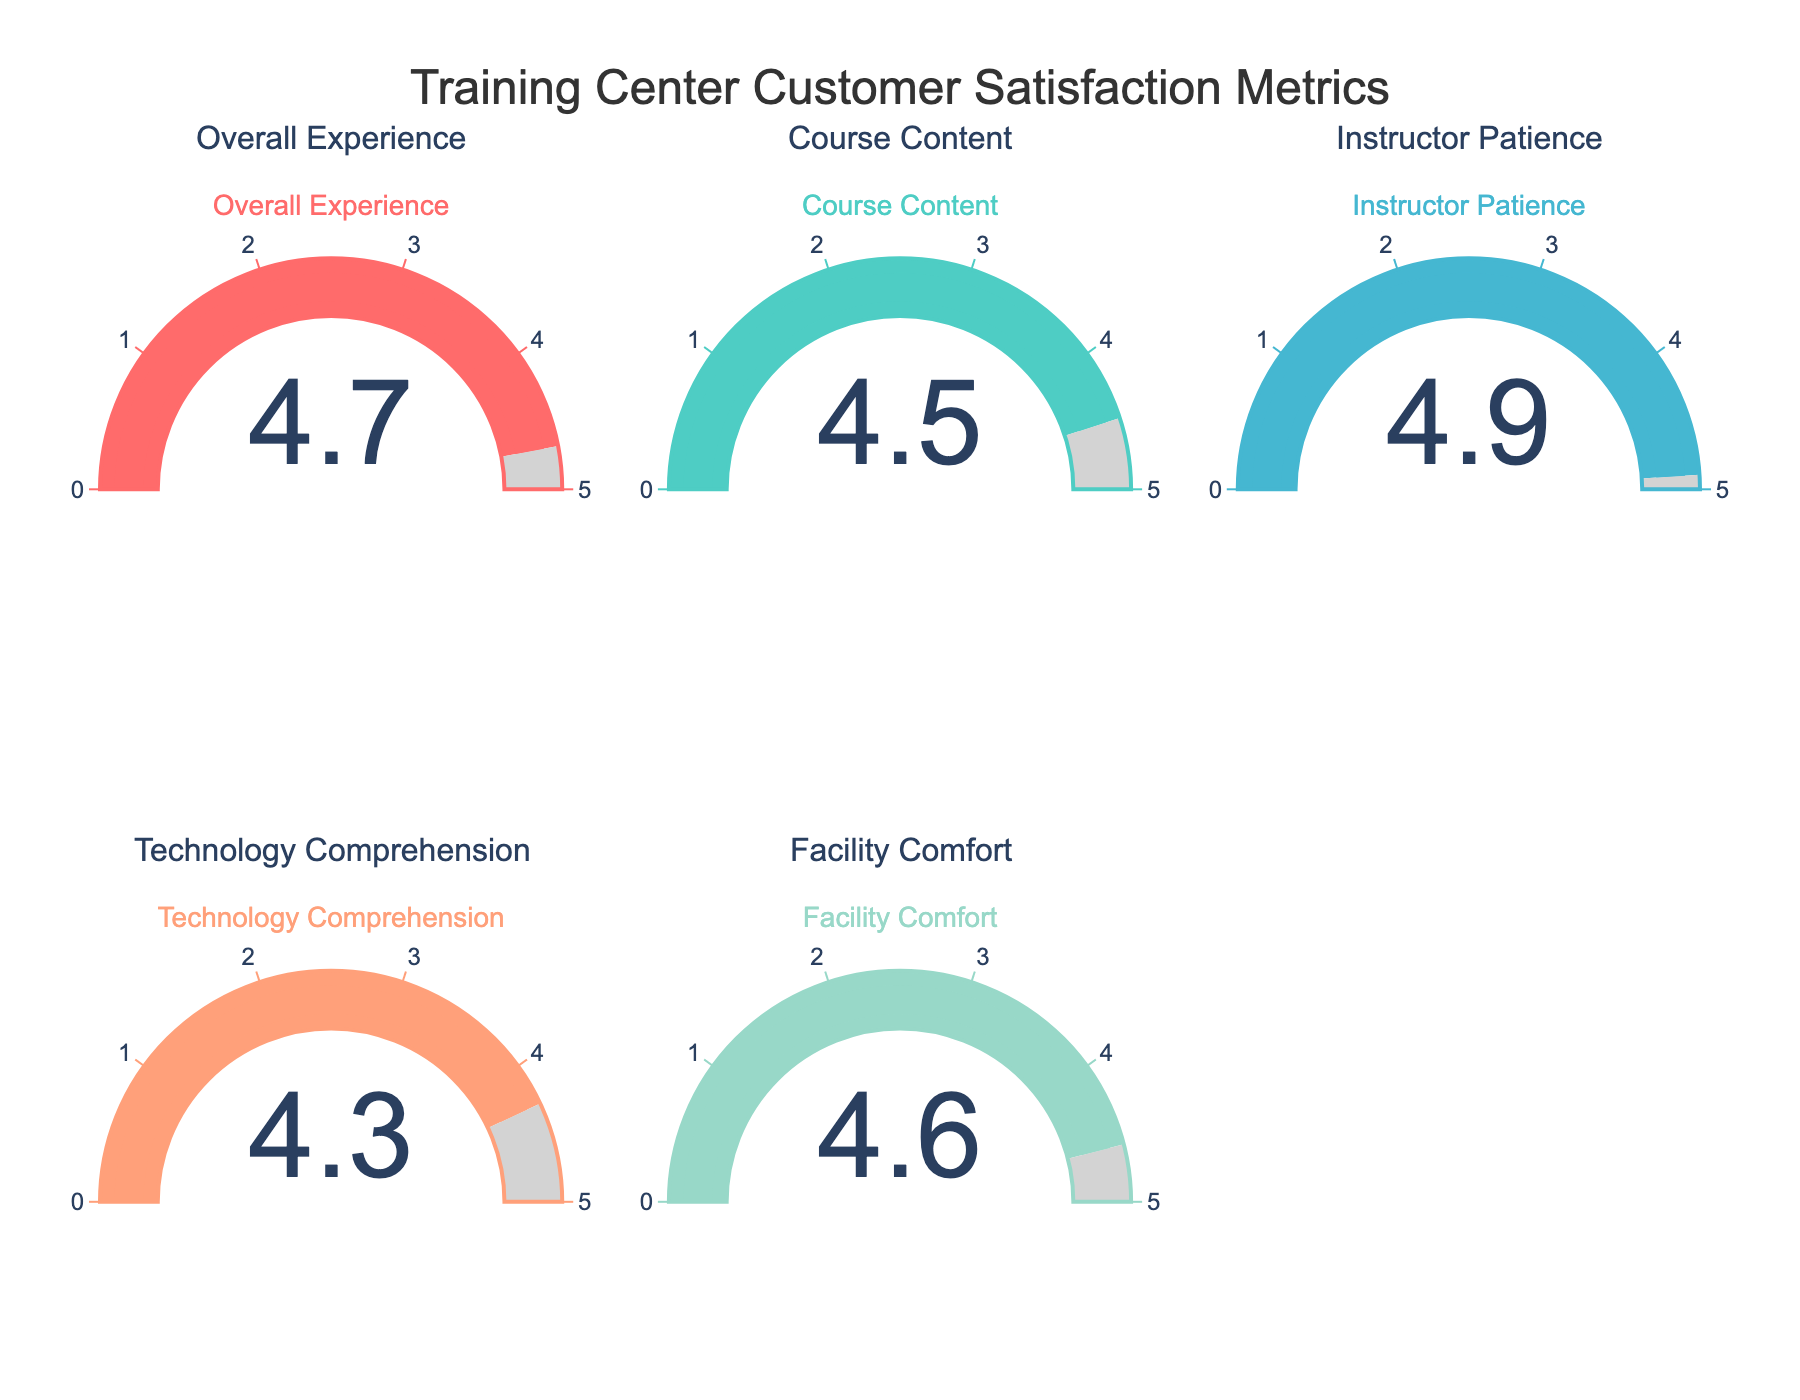What's the title of the figure? The title is usually displayed at the top of the figure. In this case, it should be clearly visible in a larger font size and say something indicative of the data shown.
Answer: Training Center Customer Satisfaction Metrics How many customer satisfaction metrics are displayed in the figure? To determine how many metrics are displayed, count the individual gauges present in the figure.
Answer: 5 Which customer satisfaction metric has the highest rating? Look for the gauge with the highest numerical value indicated. The highest rating should be 4.9.
Answer: Instructor Patience What is the range of the gauge charts? The range of the gauges is determined by the axis range, generally indicated around the gauge itself. The highest point on the gauges is expected to be 5.0.
Answer: 0 to 5 Compare the rating of 'Course Content' with 'Technology Comprehension'. Which one is higher? Find the gauges for 'Course Content' and 'Technology Comprehension' and compare the values displayed on each. The ratings are 4.5 and 4.3, respectively.
Answer: Course Content What's the average rating across all customer satisfaction metrics? Add up all the ratings and divide by the number of metrics. (4.7 + 4.5 + 4.9 + 4.3 + 4.6) / 5 = 4.6
Answer: 4.6 What is the difference between the highest and lowest ratings? Identify the highest rating (4.9 for Instructor Patience) and the lowest rating (4.3 for Technology Comprehension), and subtract the latter from the former. 4.9 - 4.3 = 0.6
Answer: 0.6 